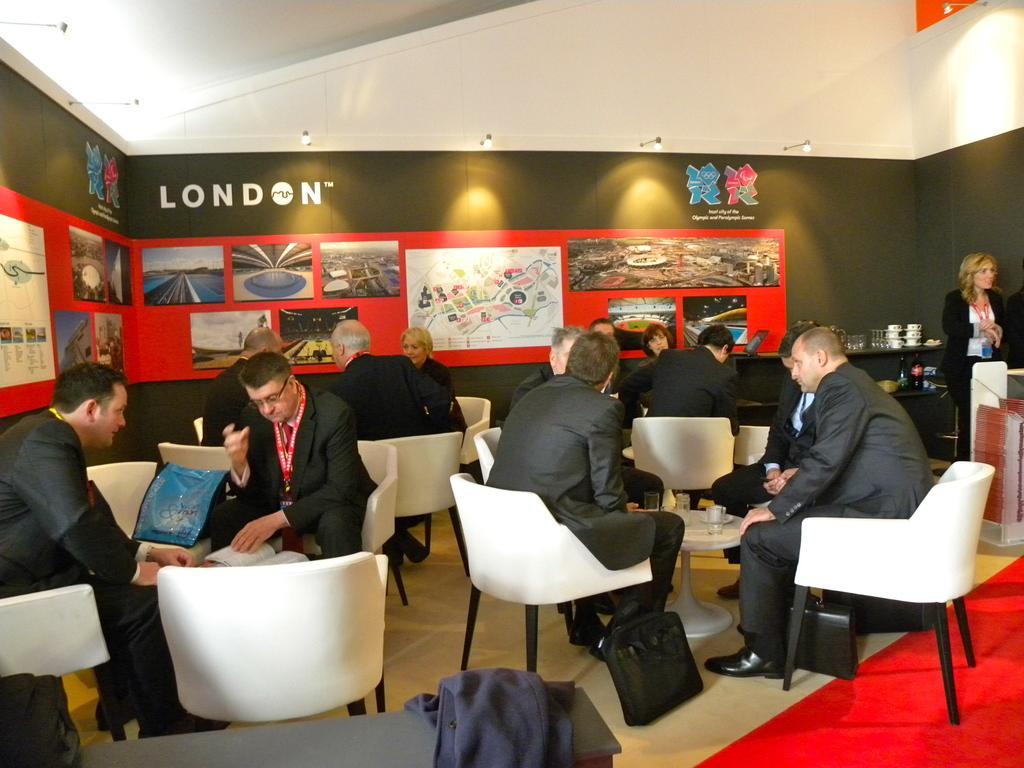Describe this image in one or two sentences. Here we can see some persons are sitting on the chairs. This is table. On the table there is a cup. This is floor. Here we can see a woman who is standing on the floor. On the background there is a wall and this is banner. And these are the lights. 